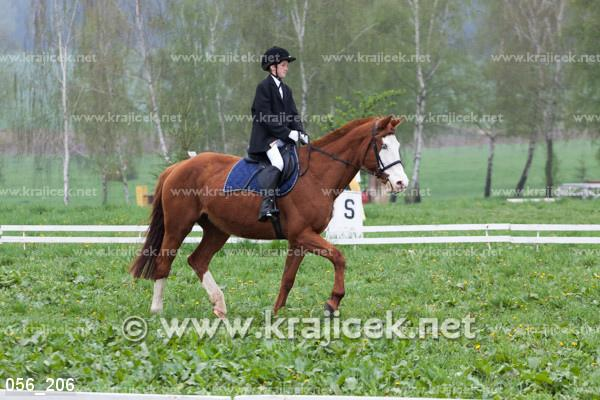What sport is this? horse riding 